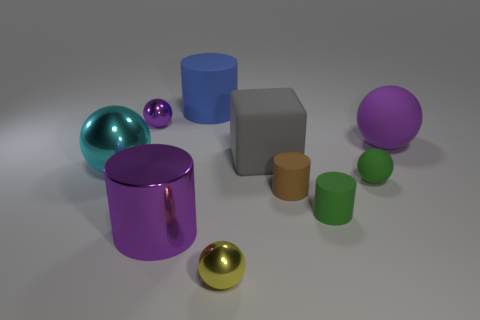Subtract all large matte spheres. How many spheres are left? 4 Subtract all yellow spheres. How many spheres are left? 4 Subtract 1 balls. How many balls are left? 4 Subtract all yellow cylinders. Subtract all cyan cubes. How many cylinders are left? 4 Subtract all cylinders. How many objects are left? 6 Subtract 0 blue blocks. How many objects are left? 10 Subtract all tiny green rubber cylinders. Subtract all small yellow spheres. How many objects are left? 8 Add 8 small purple balls. How many small purple balls are left? 9 Add 1 rubber things. How many rubber things exist? 7 